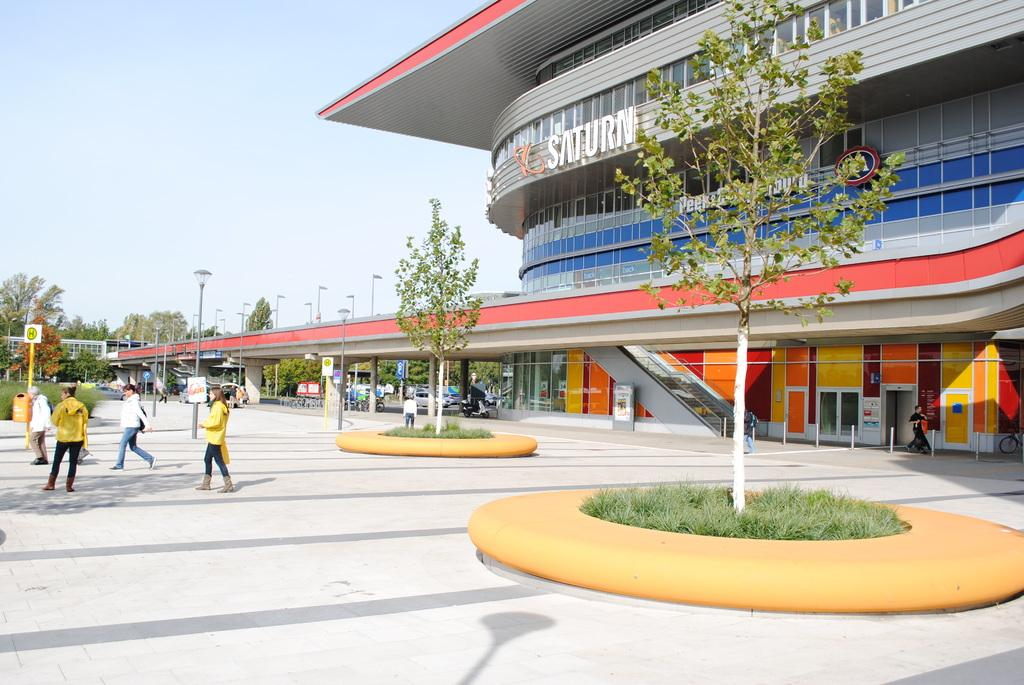<image>
Give a short and clear explanation of the subsequent image. an exterior of the Saturn building with trees in yellow circles 